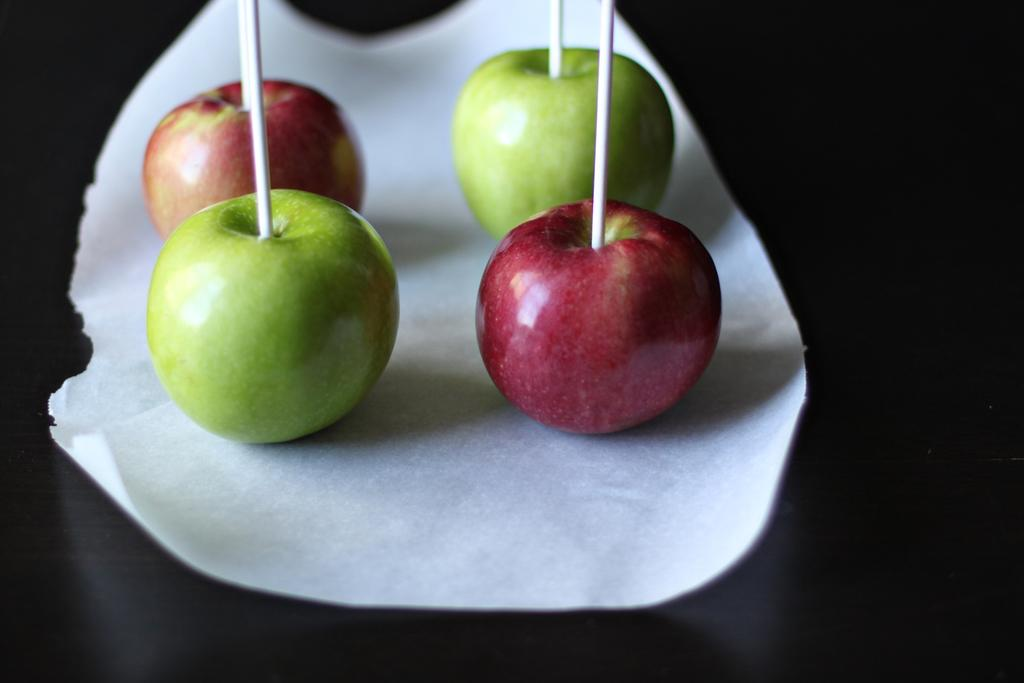What type of fruit is present in the image? There are apples in the image. What is used for cleaning or wiping in the image? There is a paper napkin in the image. Where are the apples and paper napkin located in the image? Both the apples and the paper napkin are placed on a table. What arithmetic problem can be solved using the apples in the image? There is no arithmetic problem present in the image, as it only features apples and a paper napkin on a table. What type of metal can be seen in the image? There is no metal present in the image; it only features apples and a paper napkin on a table. 